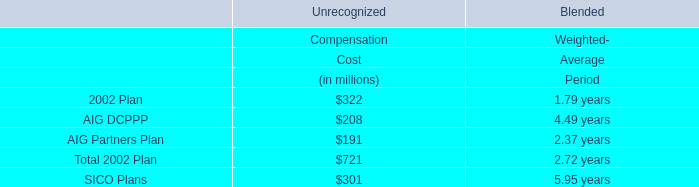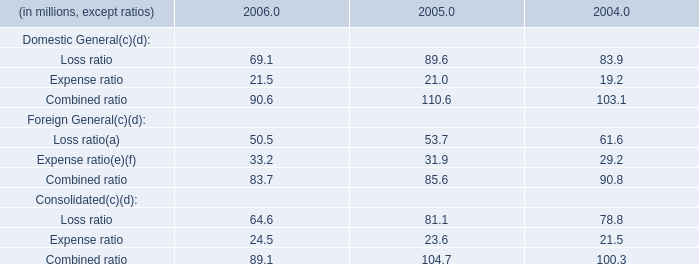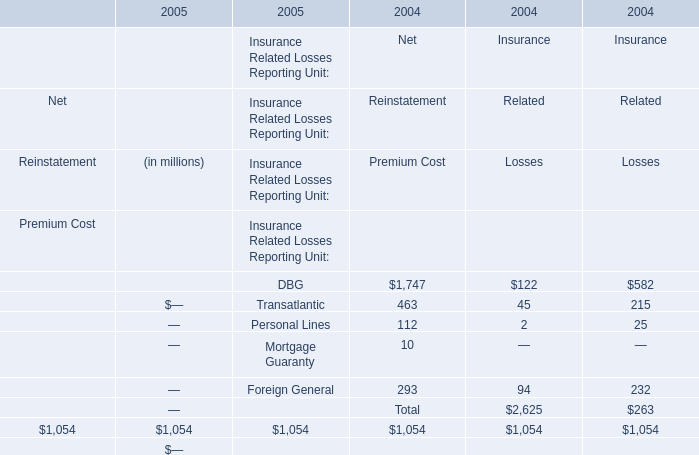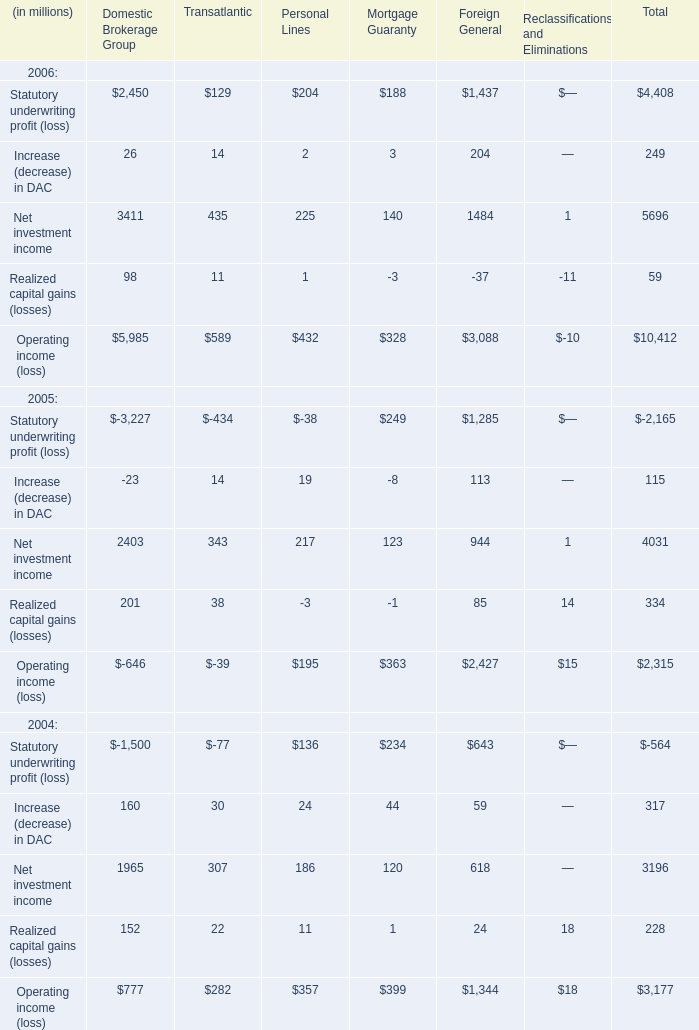What's the growth rate of Statutory underwriting profit in 2006? 
Computations: ((4408 - -2165) / 2165)
Answer: 3.03603. 